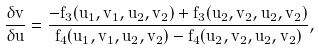Convert formula to latex. <formula><loc_0><loc_0><loc_500><loc_500>\frac { \delta v } { \delta u } = \frac { - f _ { 3 } ( u _ { 1 } , v _ { 1 } , u _ { 2 } , v _ { 2 } ) + f _ { 3 } ( u _ { 2 } , v _ { 2 } , u _ { 2 } , v _ { 2 } ) } { f _ { 4 } ( u _ { 1 } , v _ { 1 } , u _ { 2 } , v _ { 2 } ) - f _ { 4 } ( u _ { 2 } , v _ { 2 } , u _ { 2 } , v _ { 2 } ) } ,</formula> 